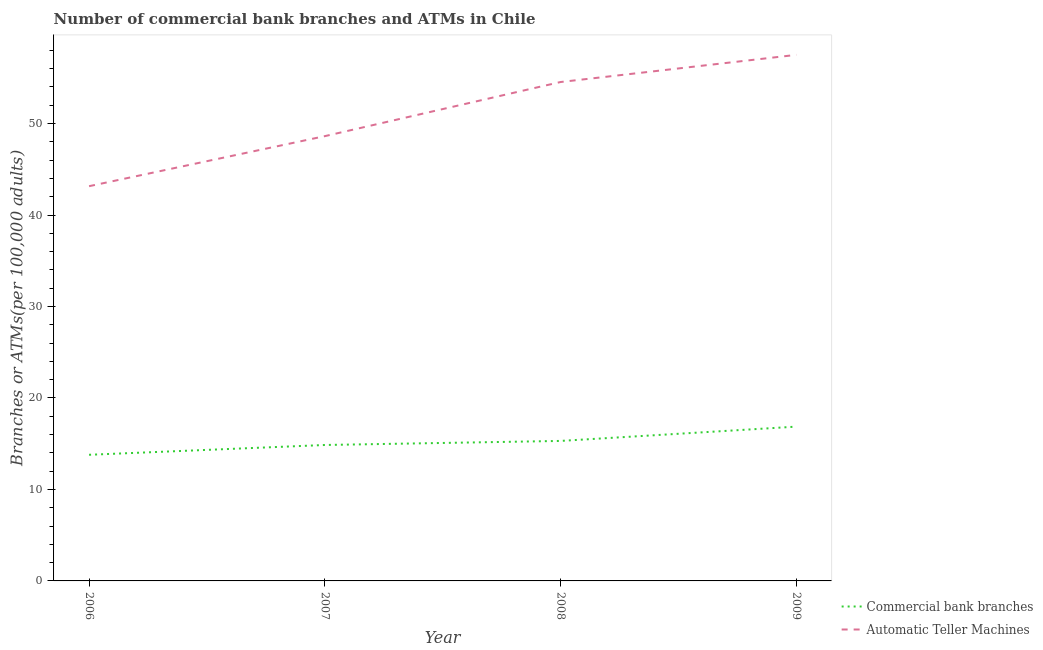What is the number of commercal bank branches in 2008?
Make the answer very short. 15.3. Across all years, what is the maximum number of atms?
Provide a succinct answer. 57.5. Across all years, what is the minimum number of atms?
Provide a short and direct response. 43.15. In which year was the number of atms maximum?
Your answer should be very brief. 2009. In which year was the number of atms minimum?
Offer a very short reply. 2006. What is the total number of commercal bank branches in the graph?
Provide a succinct answer. 60.82. What is the difference between the number of atms in 2006 and that in 2009?
Ensure brevity in your answer.  -14.36. What is the difference between the number of commercal bank branches in 2009 and the number of atms in 2008?
Provide a short and direct response. -37.67. What is the average number of atms per year?
Ensure brevity in your answer.  50.95. In the year 2006, what is the difference between the number of commercal bank branches and number of atms?
Ensure brevity in your answer.  -29.36. In how many years, is the number of commercal bank branches greater than 50?
Your answer should be very brief. 0. What is the ratio of the number of atms in 2006 to that in 2008?
Ensure brevity in your answer.  0.79. What is the difference between the highest and the second highest number of commercal bank branches?
Offer a very short reply. 1.56. What is the difference between the highest and the lowest number of atms?
Your answer should be compact. 14.36. In how many years, is the number of atms greater than the average number of atms taken over all years?
Give a very brief answer. 2. Does the number of commercal bank branches monotonically increase over the years?
Offer a terse response. Yes. Is the number of commercal bank branches strictly greater than the number of atms over the years?
Your answer should be very brief. No. How many lines are there?
Offer a very short reply. 2. What is the difference between two consecutive major ticks on the Y-axis?
Provide a short and direct response. 10. Does the graph contain grids?
Ensure brevity in your answer.  No. Where does the legend appear in the graph?
Provide a short and direct response. Bottom right. What is the title of the graph?
Your response must be concise. Number of commercial bank branches and ATMs in Chile. What is the label or title of the Y-axis?
Give a very brief answer. Branches or ATMs(per 100,0 adults). What is the Branches or ATMs(per 100,000 adults) in Commercial bank branches in 2006?
Your response must be concise. 13.79. What is the Branches or ATMs(per 100,000 adults) in Automatic Teller Machines in 2006?
Your answer should be very brief. 43.15. What is the Branches or ATMs(per 100,000 adults) of Commercial bank branches in 2007?
Give a very brief answer. 14.86. What is the Branches or ATMs(per 100,000 adults) in Automatic Teller Machines in 2007?
Offer a very short reply. 48.62. What is the Branches or ATMs(per 100,000 adults) of Commercial bank branches in 2008?
Ensure brevity in your answer.  15.3. What is the Branches or ATMs(per 100,000 adults) in Automatic Teller Machines in 2008?
Ensure brevity in your answer.  54.54. What is the Branches or ATMs(per 100,000 adults) of Commercial bank branches in 2009?
Offer a very short reply. 16.87. What is the Branches or ATMs(per 100,000 adults) in Automatic Teller Machines in 2009?
Provide a succinct answer. 57.5. Across all years, what is the maximum Branches or ATMs(per 100,000 adults) of Commercial bank branches?
Offer a terse response. 16.87. Across all years, what is the maximum Branches or ATMs(per 100,000 adults) of Automatic Teller Machines?
Give a very brief answer. 57.5. Across all years, what is the minimum Branches or ATMs(per 100,000 adults) of Commercial bank branches?
Your response must be concise. 13.79. Across all years, what is the minimum Branches or ATMs(per 100,000 adults) of Automatic Teller Machines?
Provide a short and direct response. 43.15. What is the total Branches or ATMs(per 100,000 adults) of Commercial bank branches in the graph?
Ensure brevity in your answer.  60.82. What is the total Branches or ATMs(per 100,000 adults) of Automatic Teller Machines in the graph?
Offer a very short reply. 203.81. What is the difference between the Branches or ATMs(per 100,000 adults) in Commercial bank branches in 2006 and that in 2007?
Provide a succinct answer. -1.07. What is the difference between the Branches or ATMs(per 100,000 adults) of Automatic Teller Machines in 2006 and that in 2007?
Give a very brief answer. -5.47. What is the difference between the Branches or ATMs(per 100,000 adults) of Commercial bank branches in 2006 and that in 2008?
Your answer should be compact. -1.52. What is the difference between the Branches or ATMs(per 100,000 adults) of Automatic Teller Machines in 2006 and that in 2008?
Your answer should be compact. -11.39. What is the difference between the Branches or ATMs(per 100,000 adults) in Commercial bank branches in 2006 and that in 2009?
Offer a very short reply. -3.08. What is the difference between the Branches or ATMs(per 100,000 adults) of Automatic Teller Machines in 2006 and that in 2009?
Offer a very short reply. -14.36. What is the difference between the Branches or ATMs(per 100,000 adults) of Commercial bank branches in 2007 and that in 2008?
Your response must be concise. -0.44. What is the difference between the Branches or ATMs(per 100,000 adults) in Automatic Teller Machines in 2007 and that in 2008?
Make the answer very short. -5.92. What is the difference between the Branches or ATMs(per 100,000 adults) in Commercial bank branches in 2007 and that in 2009?
Give a very brief answer. -2.01. What is the difference between the Branches or ATMs(per 100,000 adults) in Automatic Teller Machines in 2007 and that in 2009?
Your response must be concise. -8.88. What is the difference between the Branches or ATMs(per 100,000 adults) of Commercial bank branches in 2008 and that in 2009?
Keep it short and to the point. -1.56. What is the difference between the Branches or ATMs(per 100,000 adults) in Automatic Teller Machines in 2008 and that in 2009?
Offer a terse response. -2.97. What is the difference between the Branches or ATMs(per 100,000 adults) in Commercial bank branches in 2006 and the Branches or ATMs(per 100,000 adults) in Automatic Teller Machines in 2007?
Give a very brief answer. -34.83. What is the difference between the Branches or ATMs(per 100,000 adults) of Commercial bank branches in 2006 and the Branches or ATMs(per 100,000 adults) of Automatic Teller Machines in 2008?
Your response must be concise. -40.75. What is the difference between the Branches or ATMs(per 100,000 adults) in Commercial bank branches in 2006 and the Branches or ATMs(per 100,000 adults) in Automatic Teller Machines in 2009?
Keep it short and to the point. -43.72. What is the difference between the Branches or ATMs(per 100,000 adults) in Commercial bank branches in 2007 and the Branches or ATMs(per 100,000 adults) in Automatic Teller Machines in 2008?
Your answer should be compact. -39.68. What is the difference between the Branches or ATMs(per 100,000 adults) of Commercial bank branches in 2007 and the Branches or ATMs(per 100,000 adults) of Automatic Teller Machines in 2009?
Provide a short and direct response. -42.65. What is the difference between the Branches or ATMs(per 100,000 adults) in Commercial bank branches in 2008 and the Branches or ATMs(per 100,000 adults) in Automatic Teller Machines in 2009?
Give a very brief answer. -42.2. What is the average Branches or ATMs(per 100,000 adults) of Commercial bank branches per year?
Make the answer very short. 15.2. What is the average Branches or ATMs(per 100,000 adults) in Automatic Teller Machines per year?
Your response must be concise. 50.95. In the year 2006, what is the difference between the Branches or ATMs(per 100,000 adults) in Commercial bank branches and Branches or ATMs(per 100,000 adults) in Automatic Teller Machines?
Your answer should be compact. -29.36. In the year 2007, what is the difference between the Branches or ATMs(per 100,000 adults) of Commercial bank branches and Branches or ATMs(per 100,000 adults) of Automatic Teller Machines?
Your answer should be very brief. -33.76. In the year 2008, what is the difference between the Branches or ATMs(per 100,000 adults) in Commercial bank branches and Branches or ATMs(per 100,000 adults) in Automatic Teller Machines?
Make the answer very short. -39.23. In the year 2009, what is the difference between the Branches or ATMs(per 100,000 adults) of Commercial bank branches and Branches or ATMs(per 100,000 adults) of Automatic Teller Machines?
Your answer should be compact. -40.64. What is the ratio of the Branches or ATMs(per 100,000 adults) of Commercial bank branches in 2006 to that in 2007?
Offer a terse response. 0.93. What is the ratio of the Branches or ATMs(per 100,000 adults) in Automatic Teller Machines in 2006 to that in 2007?
Offer a terse response. 0.89. What is the ratio of the Branches or ATMs(per 100,000 adults) of Commercial bank branches in 2006 to that in 2008?
Offer a terse response. 0.9. What is the ratio of the Branches or ATMs(per 100,000 adults) of Automatic Teller Machines in 2006 to that in 2008?
Your response must be concise. 0.79. What is the ratio of the Branches or ATMs(per 100,000 adults) in Commercial bank branches in 2006 to that in 2009?
Your response must be concise. 0.82. What is the ratio of the Branches or ATMs(per 100,000 adults) of Automatic Teller Machines in 2006 to that in 2009?
Ensure brevity in your answer.  0.75. What is the ratio of the Branches or ATMs(per 100,000 adults) in Automatic Teller Machines in 2007 to that in 2008?
Provide a short and direct response. 0.89. What is the ratio of the Branches or ATMs(per 100,000 adults) in Commercial bank branches in 2007 to that in 2009?
Your answer should be compact. 0.88. What is the ratio of the Branches or ATMs(per 100,000 adults) of Automatic Teller Machines in 2007 to that in 2009?
Your answer should be compact. 0.85. What is the ratio of the Branches or ATMs(per 100,000 adults) of Commercial bank branches in 2008 to that in 2009?
Keep it short and to the point. 0.91. What is the ratio of the Branches or ATMs(per 100,000 adults) of Automatic Teller Machines in 2008 to that in 2009?
Offer a terse response. 0.95. What is the difference between the highest and the second highest Branches or ATMs(per 100,000 adults) of Commercial bank branches?
Offer a very short reply. 1.56. What is the difference between the highest and the second highest Branches or ATMs(per 100,000 adults) of Automatic Teller Machines?
Make the answer very short. 2.97. What is the difference between the highest and the lowest Branches or ATMs(per 100,000 adults) of Commercial bank branches?
Offer a terse response. 3.08. What is the difference between the highest and the lowest Branches or ATMs(per 100,000 adults) in Automatic Teller Machines?
Provide a succinct answer. 14.36. 